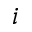Convert formula to latex. <formula><loc_0><loc_0><loc_500><loc_500>i</formula> 